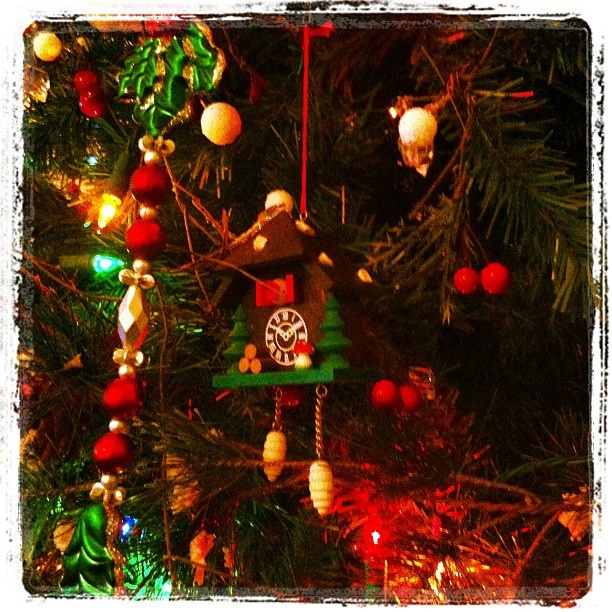Describe the objects in this image and their specific colors. I can see a clock in white, maroon, tan, and brown tones in this image. 